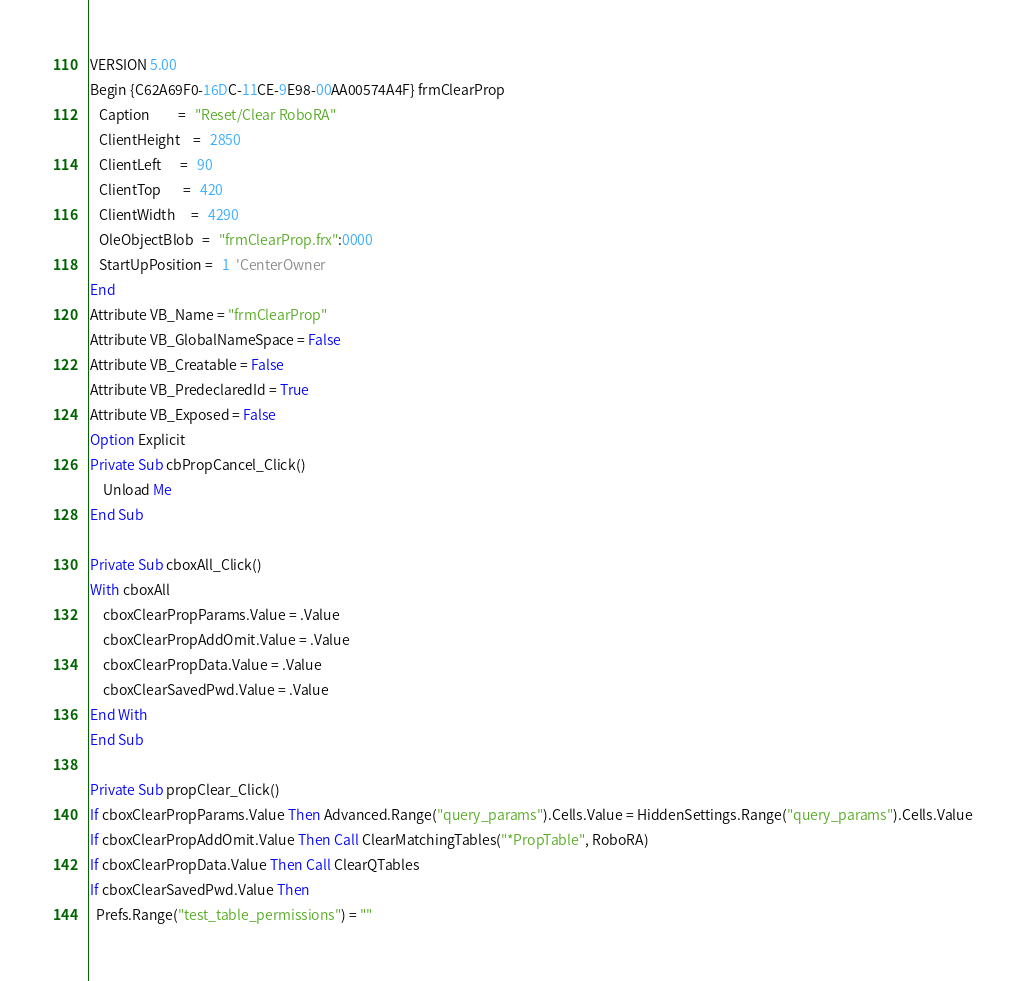<code> <loc_0><loc_0><loc_500><loc_500><_VisualBasic_>VERSION 5.00
Begin {C62A69F0-16DC-11CE-9E98-00AA00574A4F} frmClearProp 
   Caption         =   "Reset/Clear RoboRA"
   ClientHeight    =   2850
   ClientLeft      =   90
   ClientTop       =   420
   ClientWidth     =   4290
   OleObjectBlob   =   "frmClearProp.frx":0000
   StartUpPosition =   1  'CenterOwner
End
Attribute VB_Name = "frmClearProp"
Attribute VB_GlobalNameSpace = False
Attribute VB_Creatable = False
Attribute VB_PredeclaredId = True
Attribute VB_Exposed = False
Option Explicit
Private Sub cbPropCancel_Click()
    Unload Me
End Sub

Private Sub cboxAll_Click()
With cboxAll
    cboxClearPropParams.Value = .Value
    cboxClearPropAddOmit.Value = .Value
    cboxClearPropData.Value = .Value
    cboxClearSavedPwd.Value = .Value
End With
End Sub

Private Sub propClear_Click()
If cboxClearPropParams.Value Then Advanced.Range("query_params").Cells.Value = HiddenSettings.Range("query_params").Cells.Value
If cboxClearPropAddOmit.Value Then Call ClearMatchingTables("*PropTable", RoboRA)
If cboxClearPropData.Value Then Call ClearQTables
If cboxClearSavedPwd.Value Then
  Prefs.Range("test_table_permissions") = ""</code> 